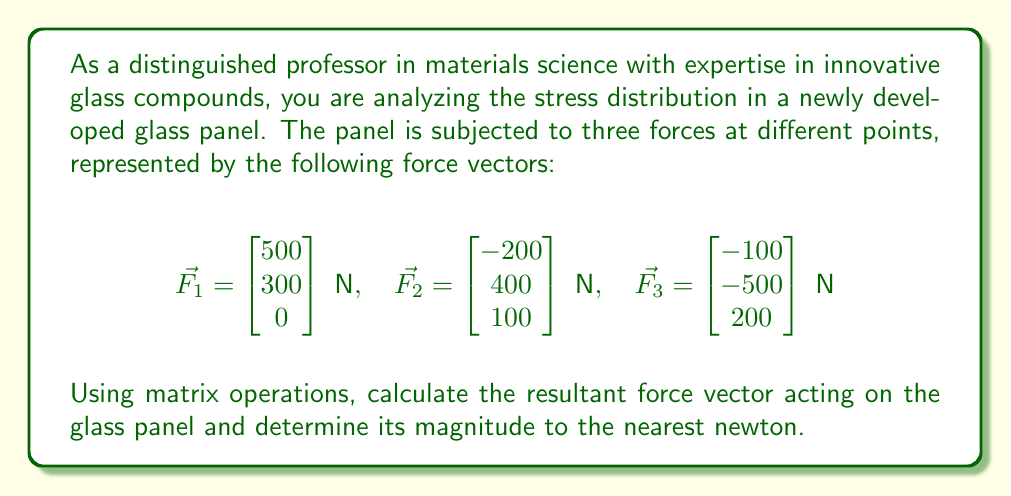Can you solve this math problem? To solve this problem, we'll follow these steps:

1) First, we need to find the resultant force vector by adding all the individual force vectors. We can do this using matrix addition:

   $$\vec{F_{resultant}} = \vec{F_1} + \vec{F_2} + \vec{F_3}$$

   $$\begin{bmatrix} 500 \\ 300 \\ 0 \end{bmatrix} + \begin{bmatrix} -200 \\ 400 \\ 100 \end{bmatrix} + \begin{bmatrix} -100 \\ -500 \\ 200 \end{bmatrix}$$

2) Perform the matrix addition:

   $$\vec{F_{resultant}} = \begin{bmatrix} 500 - 200 - 100 \\ 300 + 400 - 500 \\ 0 + 100 + 200 \end{bmatrix} = \begin{bmatrix} 200 \\ 200 \\ 300 \end{bmatrix} \text{ N}$$

3) Now that we have the resultant force vector, we need to calculate its magnitude. The magnitude of a vector is given by the square root of the sum of the squares of its components:

   $$|\vec{F_{resultant}}| = \sqrt{F_x^2 + F_y^2 + F_z^2}$$

4) Substitute the values:

   $$|\vec{F_{resultant}}| = \sqrt{200^2 + 200^2 + 300^2}$$

5) Calculate:

   $$|\vec{F_{resultant}}| = \sqrt{40,000 + 40,000 + 90,000} = \sqrt{170,000} \approx 412.31 \text{ N}$$

6) Rounding to the nearest newton:

   $$|\vec{F_{resultant}}| \approx 412 \text{ N}$$
Answer: The resultant force vector is $\vec{F_{resultant}} = \begin{bmatrix} 200 \\ 200 \\ 300 \end{bmatrix} \text{ N}$, and its magnitude is approximately 412 N. 